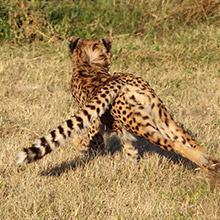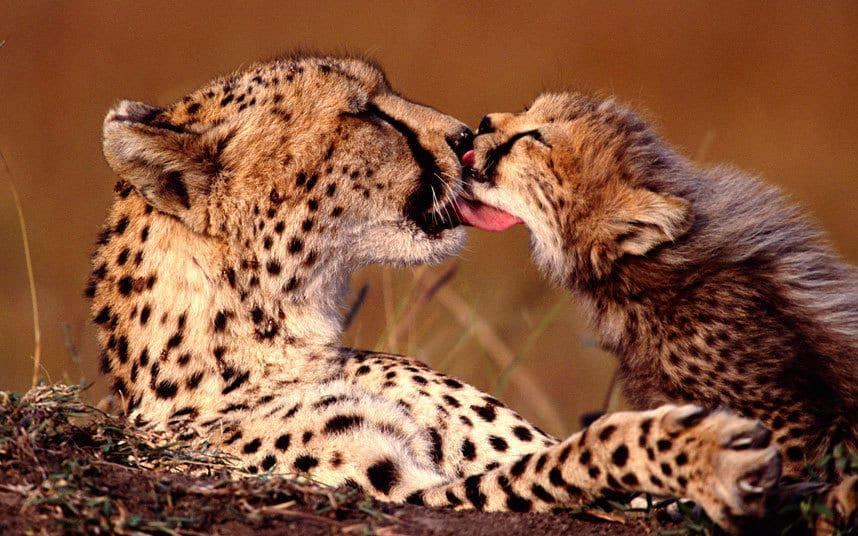The first image is the image on the left, the second image is the image on the right. For the images shown, is this caption "There is one cheetah in the left image and two cheetahs in the right image" true? Answer yes or no. Yes. The first image is the image on the left, the second image is the image on the right. Assess this claim about the two images: "Cheeta cubs are playing with moms tail". Correct or not? Answer yes or no. No. 